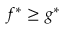Convert formula to latex. <formula><loc_0><loc_0><loc_500><loc_500>f ^ { * } \geq g ^ { * }</formula> 